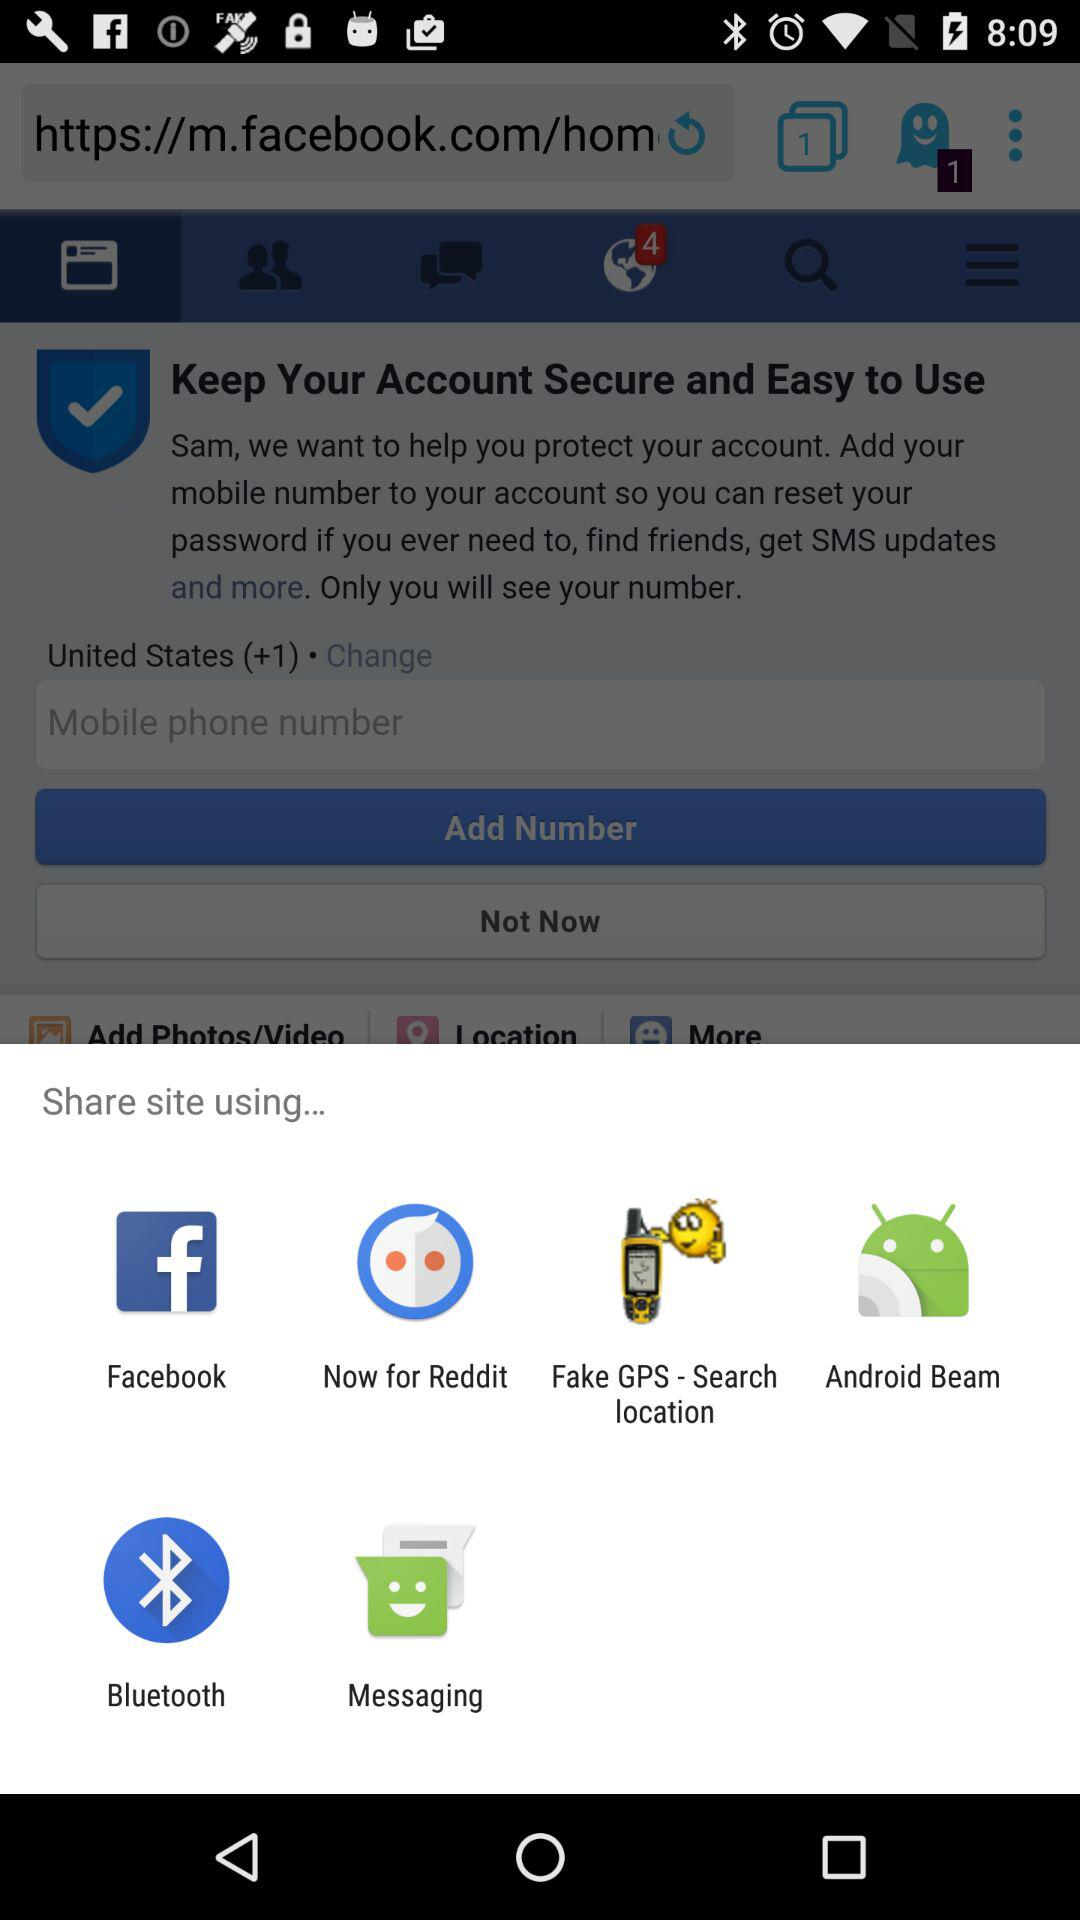What applications can be used to share? The applications that can be used to share are "Facebook", "Now for Reddit", "Fake GPS - Search location", "Android Beam", "Bluetooth" and "Messaging". 